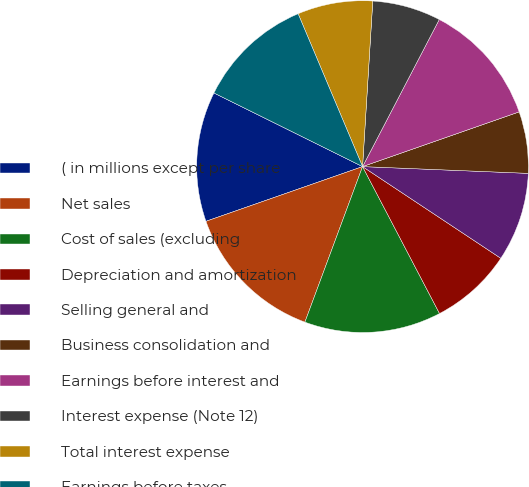Convert chart. <chart><loc_0><loc_0><loc_500><loc_500><pie_chart><fcel>( in millions except per share<fcel>Net sales<fcel>Cost of sales (excluding<fcel>Depreciation and amortization<fcel>Selling general and<fcel>Business consolidation and<fcel>Earnings before interest and<fcel>Interest expense (Note 12)<fcel>Total interest expense<fcel>Earnings before taxes<nl><fcel>12.67%<fcel>14.0%<fcel>13.33%<fcel>8.0%<fcel>8.67%<fcel>6.0%<fcel>12.0%<fcel>6.67%<fcel>7.33%<fcel>11.33%<nl></chart> 